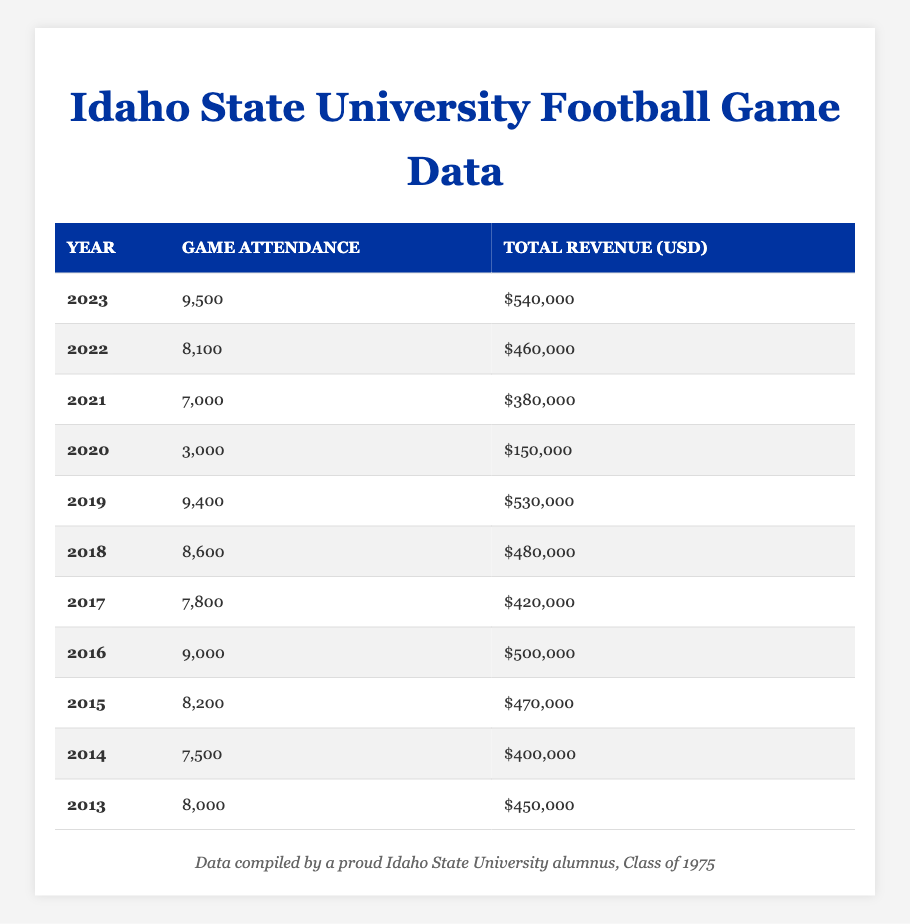What was the game attendance in 2023? The table shows that the game attendance for the year 2023 is listed directly under the "Game Attendance" column. It displays the value “9,500.”
Answer: 9,500 Which year had the highest total revenue? By examining the "Total Revenue (USD)" column, the year with the highest value is 2023, showing a revenue of "$540,000."
Answer: 2023 What was the total revenue decrease from 2019 to 2020? The total revenue for 2019 is $530,000 and for 2020 it is $150,000. The decrease can be calculated as $530,000 - $150,000 = $380,000.
Answer: $380,000 What was the average game attendance over the last decade? To find the average, sum the game attendance values: (8,000 + 7,500 + 8,200 + 9,000 + 7,800 + 8,600 + 9,400 + 3,000 + 7,000 + 8,100 + 9,500) = 66,100. There are 11 years, so the average is 66,100 / 11 = 6,010.
Answer: 6,010 Was the game attendance in 2021 higher than in 2013? The game attendance in 2021 is 7,000 and in 2013 it is 8,000. Since 7,000 is less than 8,000, the statement is false.
Answer: No What was the total revenue for the years with attendance over 8,000? The years with attendance over 8,000 are 2015, 2016, 2018, 2019, 2022, and 2023. Their corresponding revenues are $470,000, $500,000, $480,000, $530,000, $460,000, and $540,000. The total revenue is $470,000 + $500,000 + $480,000 + $530,000 + $460,000 + $540,000 = $2,980,000.
Answer: $2,980,000 In which year did the attendance drop below 4,000? By inspecting the "Game Attendance" values, we see that attendance dropped below 4,000 in 2020, where it shows an attendance of 3,000.
Answer: 2020 How much total revenue was generated from 2014 to 2016? The revenues for 2014, 2015, and 2016 are $400,000, $470,000, and $500,000, respectively. Summing these yields $400,000 + $470,000 + $500,000 = $1,370,000.
Answer: $1,370,000 Did the total revenue in 2018 exceed the total revenue in 2017? Checking the revenues, 2018 had $480,000 and 2017 had $420,000. Since $480,000 is greater than $420,000, the statement is true.
Answer: Yes What is the difference in game attendance between the highest and lowest year in the last decade? The highest attendance was in 2023 with 9,500, and the lowest was in 2020 with 3,000. The difference is calculated as 9,500 - 3,000 = 6,500.
Answer: 6,500 